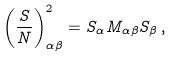Convert formula to latex. <formula><loc_0><loc_0><loc_500><loc_500>\left ( \frac { S } { N } \right ) ^ { 2 } _ { \alpha \beta } = S _ { \alpha } M _ { \alpha \beta } S _ { \beta } \, ,</formula> 